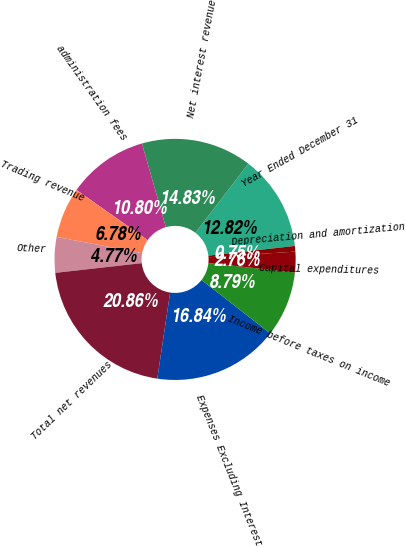Convert chart to OTSL. <chart><loc_0><loc_0><loc_500><loc_500><pie_chart><fcel>Year Ended December 31<fcel>Net interest revenue<fcel>administration fees<fcel>Trading revenue<fcel>Other<fcel>Total net revenues<fcel>Expenses Excluding Interest<fcel>Income before taxes on income<fcel>Capital expenditures<fcel>Depreciation and amortization<nl><fcel>12.82%<fcel>14.83%<fcel>10.8%<fcel>6.78%<fcel>4.77%<fcel>20.86%<fcel>16.84%<fcel>8.79%<fcel>2.76%<fcel>0.75%<nl></chart> 